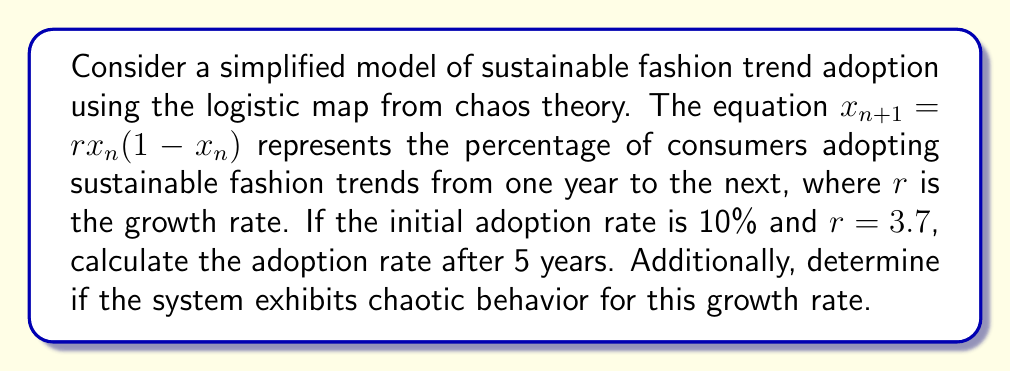Help me with this question. 1. The logistic map is given by $x_{n+1} = rx_n(1-x_n)$, where $x_n$ represents the adoption rate in year $n$.

2. Given: $x_0 = 0.10$ (initial adoption rate) and $r = 3.7$ (growth rate)

3. Calculate the adoption rate for each year:

   Year 1: $x_1 = 3.7 \cdot 0.10 \cdot (1-0.10) = 0.333$
   Year 2: $x_2 = 3.7 \cdot 0.333 \cdot (1-0.333) = 0.8235$
   Year 3: $x_3 = 3.7 \cdot 0.8235 \cdot (1-0.8235) = 0.5379$
   Year 4: $x_4 = 3.7 \cdot 0.5379 \cdot (1-0.5379) = 0.9201$
   Year 5: $x_5 = 3.7 \cdot 0.9201 \cdot (1-0.9201) = 0.2716$

4. The adoption rate after 5 years is approximately 27.16%.

5. To determine if the system exhibits chaotic behavior, we need to consider the Lyapunov exponent ($\lambda$) for the given growth rate:

   $\lambda = \lim_{n \to \infty} \frac{1}{n} \sum_{i=0}^{n-1} \ln|r(1-2x_i)|$

   For $r = 3.7$, the Lyapunov exponent is positive ($\lambda \approx 0.36$), indicating chaotic behavior.

6. Additionally, we can observe that the adoption rates do not converge to a stable value or periodic cycle, further confirming chaotic behavior.
Answer: 27.16%; chaotic behavior 